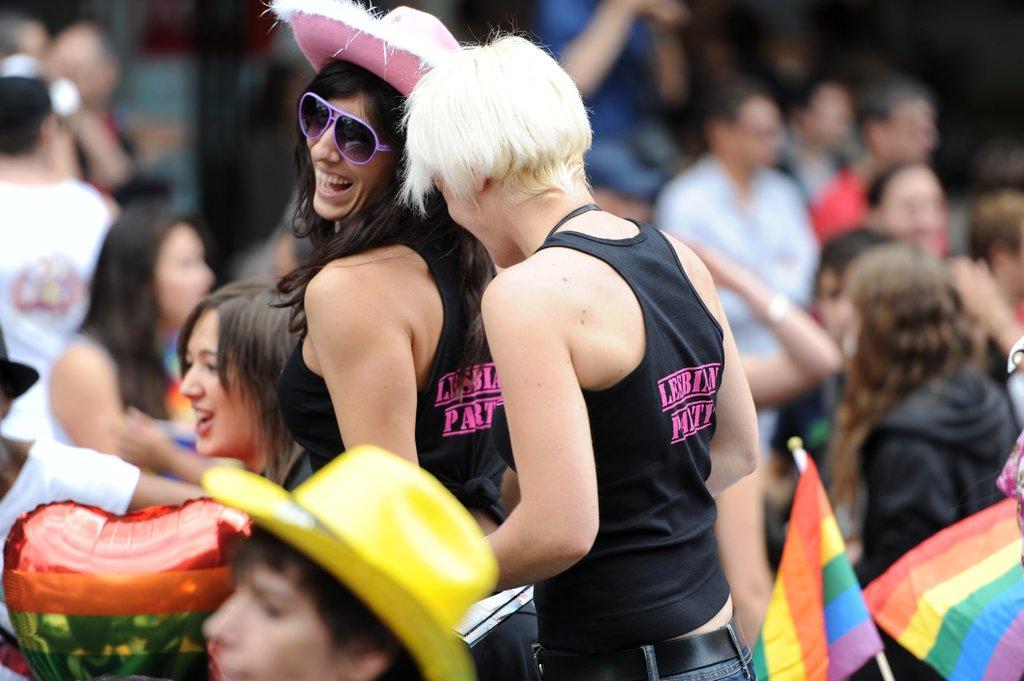How would you summarize this image in a sentence or two? In the image we can see there are many people wearing clothes and some of them are wearing a cap. This is a flag, goggles and a balloon, and they are smiling. 